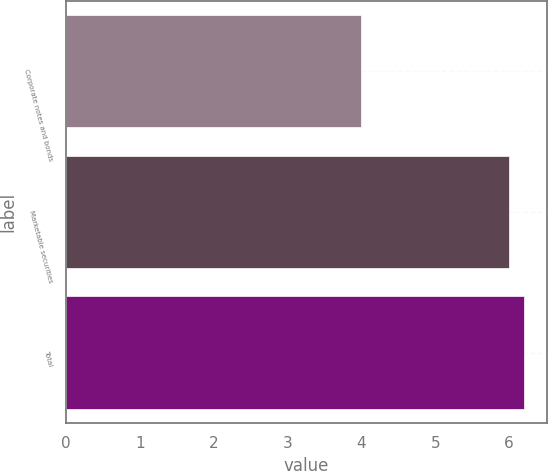Convert chart to OTSL. <chart><loc_0><loc_0><loc_500><loc_500><bar_chart><fcel>Corporate notes and bonds<fcel>Marketable securities<fcel>Total<nl><fcel>4<fcel>6<fcel>6.2<nl></chart> 